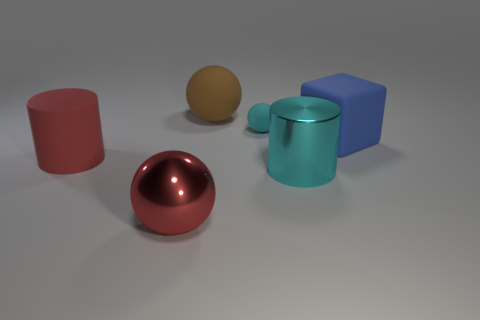Are there any large spheres that have the same color as the large rubber cylinder?
Your answer should be compact. Yes. There is a matte cube that is the same size as the brown rubber ball; what is its color?
Your answer should be compact. Blue. What shape is the large matte object on the right side of the large metal thing that is right of the matte ball that is behind the tiny rubber ball?
Keep it short and to the point. Cube. There is a red thing that is behind the large cyan shiny object; what number of metal things are to the left of it?
Provide a succinct answer. 0. There is a large brown matte object to the left of the tiny cyan thing; is its shape the same as the big matte thing on the right side of the brown rubber ball?
Provide a succinct answer. No. There is a brown sphere; what number of brown matte things are behind it?
Offer a very short reply. 0. Does the big red thing that is in front of the metal cylinder have the same material as the large cyan object?
Give a very brief answer. Yes. There is a tiny matte thing that is the same shape as the large brown thing; what color is it?
Your answer should be compact. Cyan. There is a big brown thing; what shape is it?
Provide a succinct answer. Sphere. What number of things are either tiny cyan spheres or large cubes?
Your response must be concise. 2. 